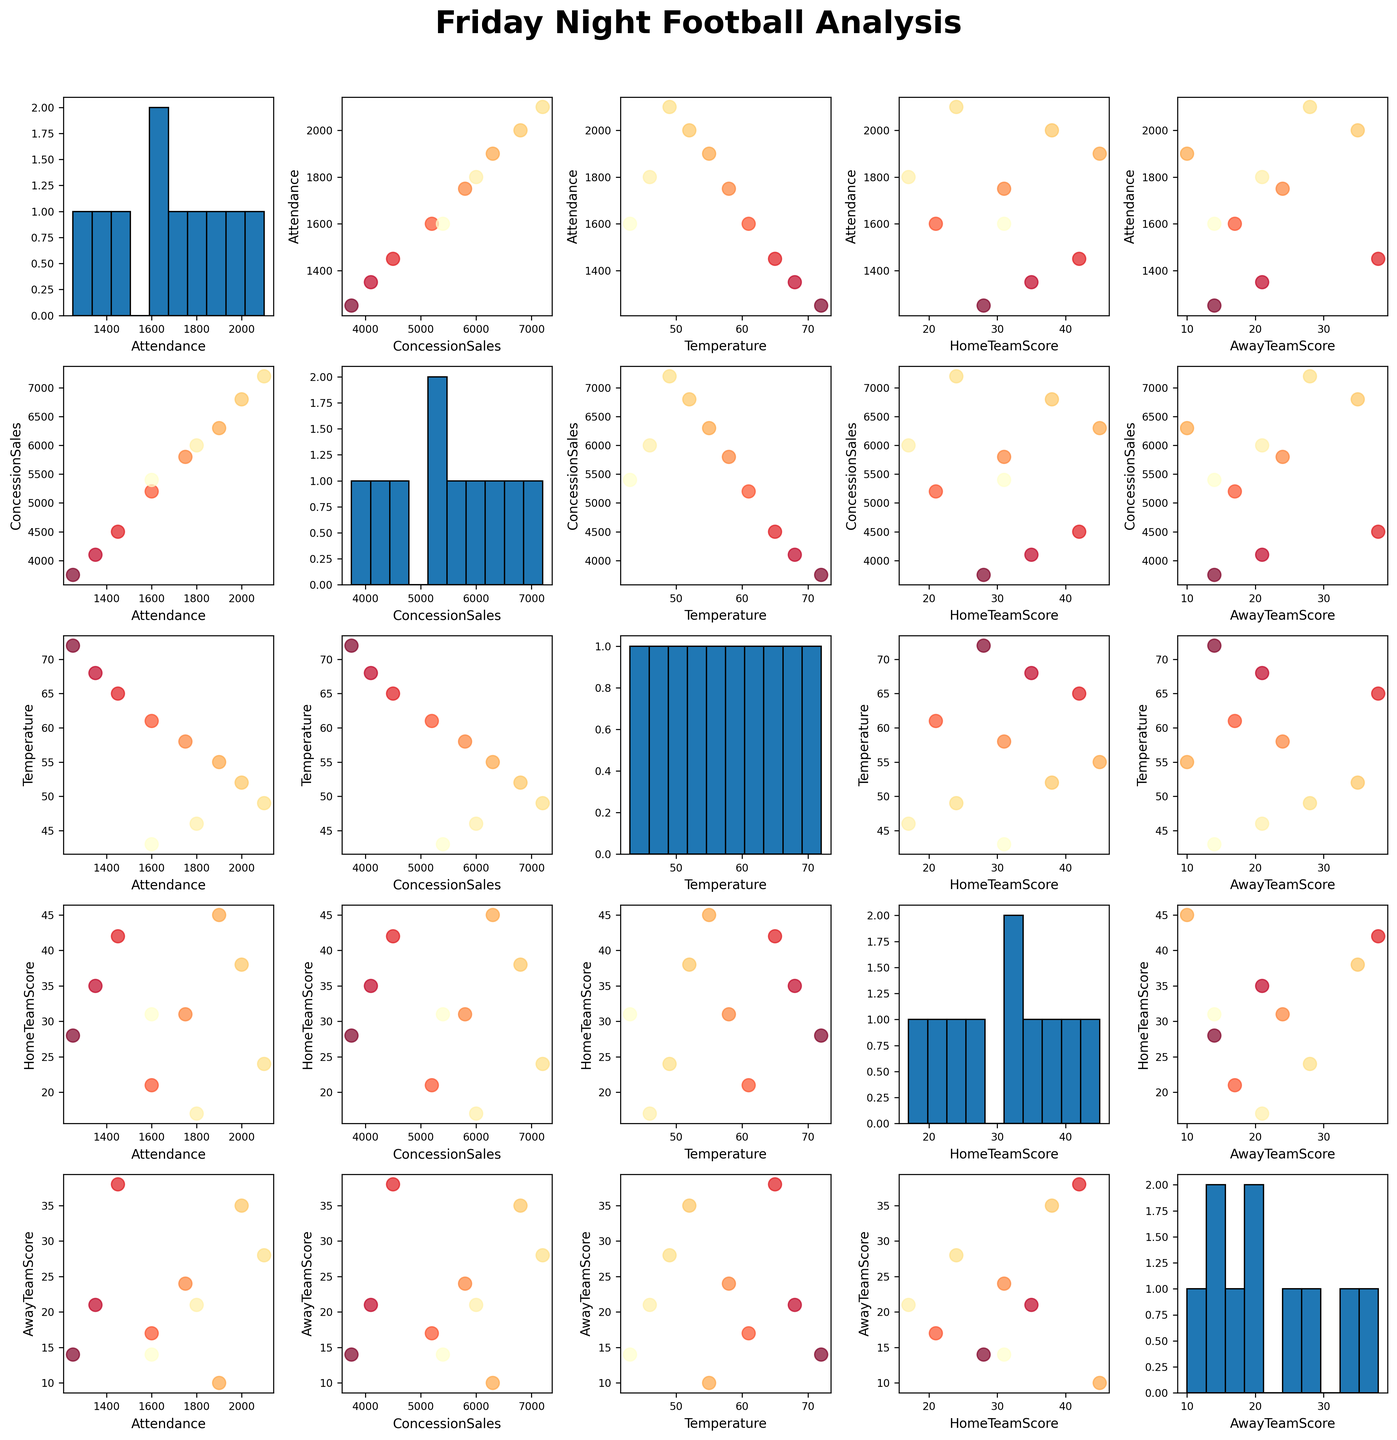What is the title of the figure? The title of the figure can be found at the top, usually in bold and larger font. It reads, "Friday Night Football Analysis."
Answer: Friday Night Football Analysis How many different variables are visualized in the scatterplot matrix? The variables are displayed on the axes of each scatterplot. The scatterplot matrix contains variables: Attendance, ConcessionSales, Temperature, HomeTeamScore, and AwayTeamScore, which total to 5.
Answer: 5 What type of plot is used along the diagonal of the scatterplot matrix? Along the diagonal, histograms are used instead of scatterplots. Each histogram represents the distribution of a single variable.
Answer: Histograms Between which variables does the scatterplot show a positive relationship? By examining the scatterplots, a positive relationship means that as one variable increases, the other does too. For instance, Attendance and ConcessionSales show a positive trend.
Answer: Attendance and ConcessionSales How does Attendance change over the season? We can analyze the Attendance histogram to see how frequently different attendance figures occur. Higher attendance is more frequent in the latter part of the season.
Answer: Increases Which variable shows the highest variation in its histogram? The histogram with the widest spread (largest range) indicates the highest variation. ConcessionSales shows a broad range from 3750 to 7200.
Answer: ConcessionSales Is there a relationship between Temperature and HomeTeamScore? Checking the scatterplot between Temperature (x-axis) and HomeTeamScore (y-axis), there seems to be a negative trend where lower temperatures slightly correspond to higher home team scores.
Answer: Yes, negative relationship What is the average Attendance for the data points shown? By examining the Attendance histogram or calculating directly, sum the attendance figures (1250 + 1350 + 1450 + 1600 + 1750 + 1900 + 2000 + 2100 + 1800 + 1600 = 17800) and divide by the number of games (10). This gives an average of 1780.
Answer: 1780 Compare the highest AwayTeamScore with the highest HomeTeamScore in the scatterplot matrix. Looking at the scatterplots and histograms, the highest AwayTeamScore is 38, while the highest HomeTeamScore is 45.
Answer: HomeTeamScore higher How do Temperature and ConcessionSales relate visually in the scatterplot matrix? Observing the scatterplot between Temperature (x-axis) and ConcessionSales (y-axis), there seems to be a negative correlation where lower temperatures correspond to higher concession sales.
Answer: Negative correlation 